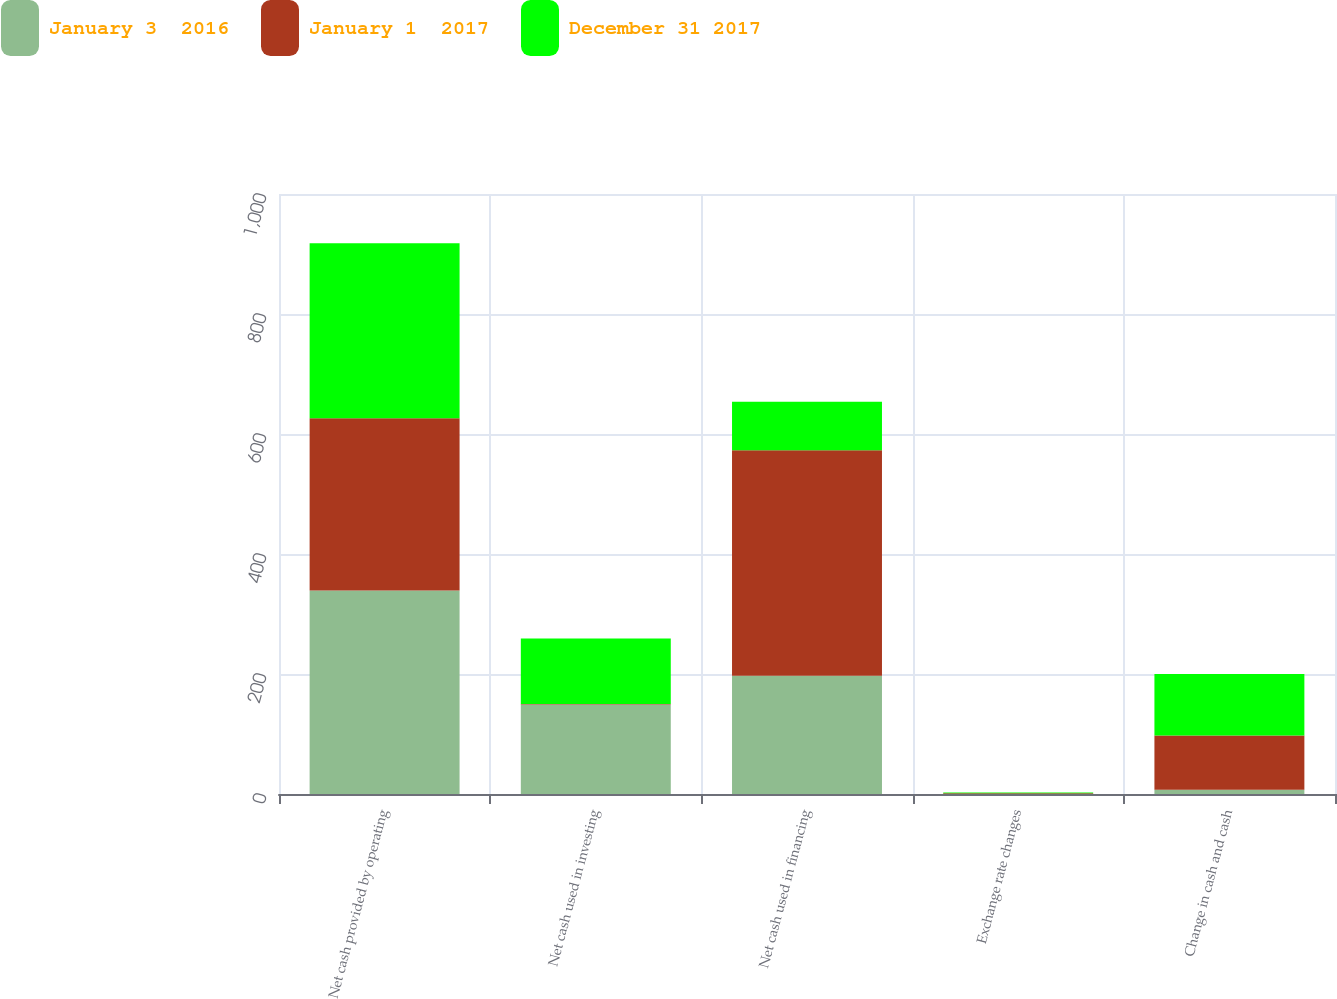Convert chart to OTSL. <chart><loc_0><loc_0><loc_500><loc_500><stacked_bar_chart><ecel><fcel>Net cash provided by operating<fcel>Net cash used in investing<fcel>Net cash used in financing<fcel>Exchange rate changes<fcel>Change in cash and cash<nl><fcel>January 3  2016<fcel>339<fcel>149<fcel>197.1<fcel>0.1<fcel>7<nl><fcel>January 1  2017<fcel>287.3<fcel>0.8<fcel>375.8<fcel>1.3<fcel>90.6<nl><fcel>December 31 2017<fcel>291.8<fcel>109.3<fcel>80.9<fcel>1<fcel>102.6<nl></chart> 